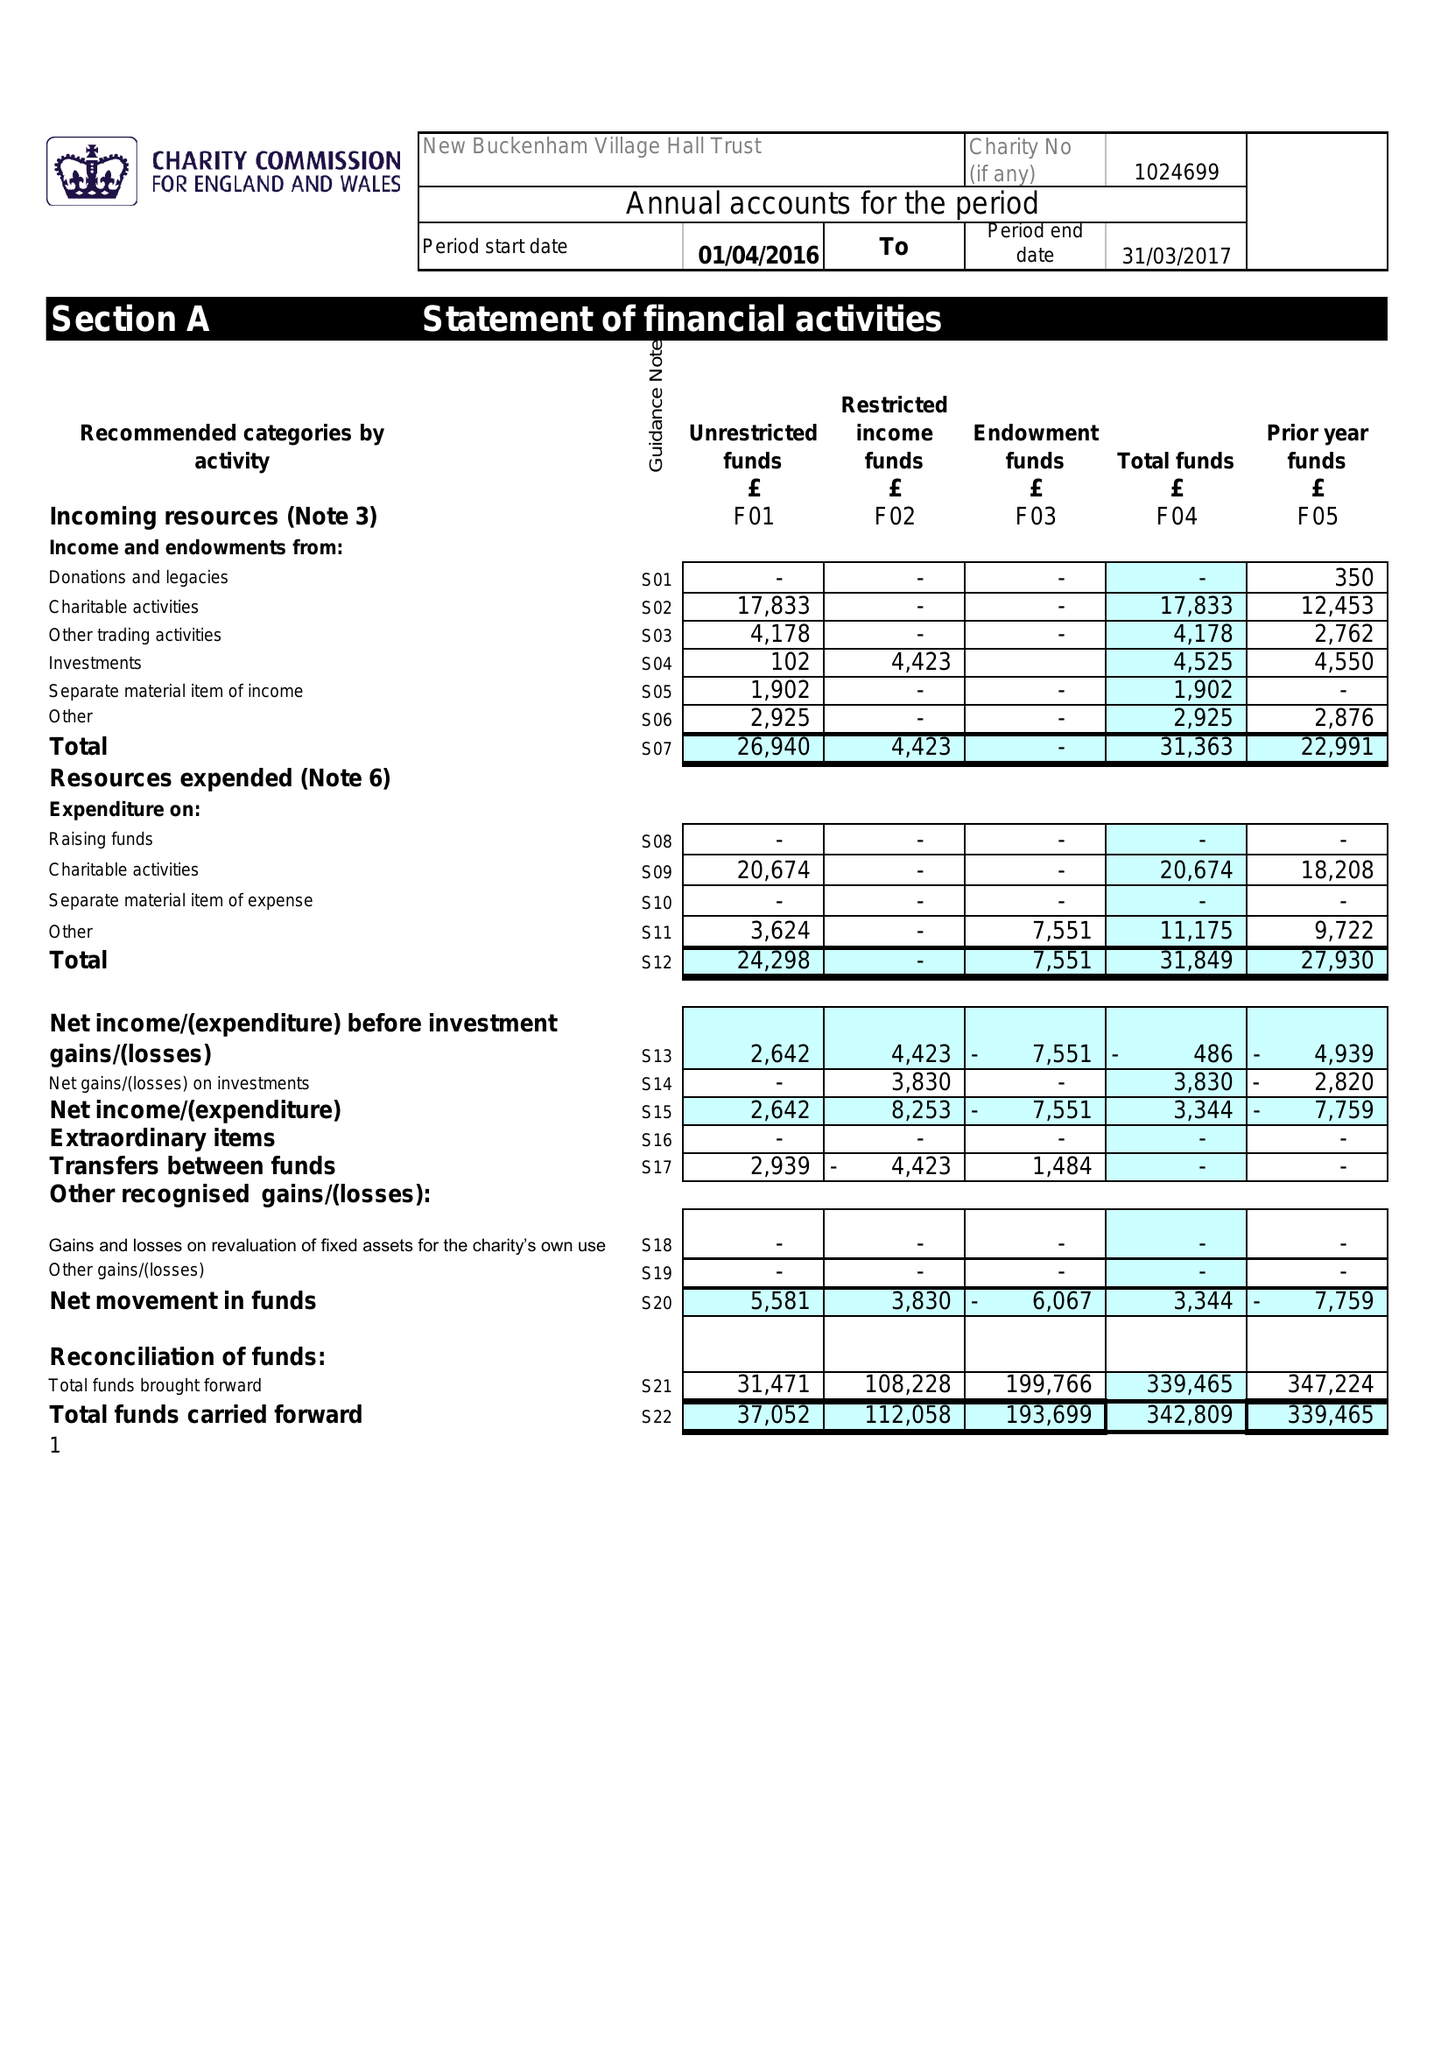What is the value for the address__post_town?
Answer the question using a single word or phrase. NORWICH 